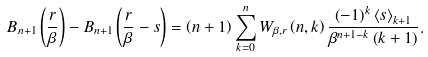Convert formula to latex. <formula><loc_0><loc_0><loc_500><loc_500>B _ { n + 1 } \left ( \frac { r } { \beta } \right ) - B _ { n + 1 } \left ( \frac { r } { \beta } - s \right ) = \left ( n + 1 \right ) \sum _ { k = 0 } ^ { n } W _ { \beta , r } \left ( n , k \right ) \frac { \left ( - 1 \right ) ^ { k } \left \langle s \right \rangle _ { k + 1 } } { \beta ^ { n + 1 - k } \left ( k + 1 \right ) } .</formula> 